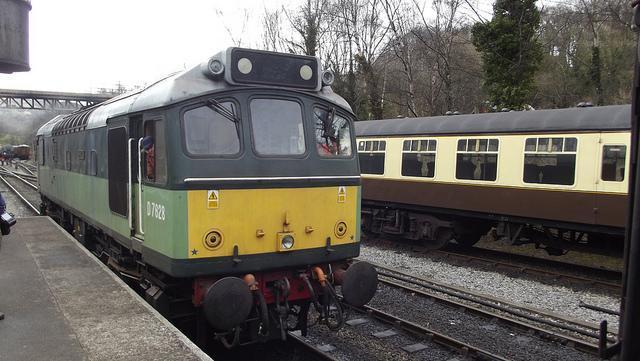How many trains are there?
Give a very brief answer. 2. 